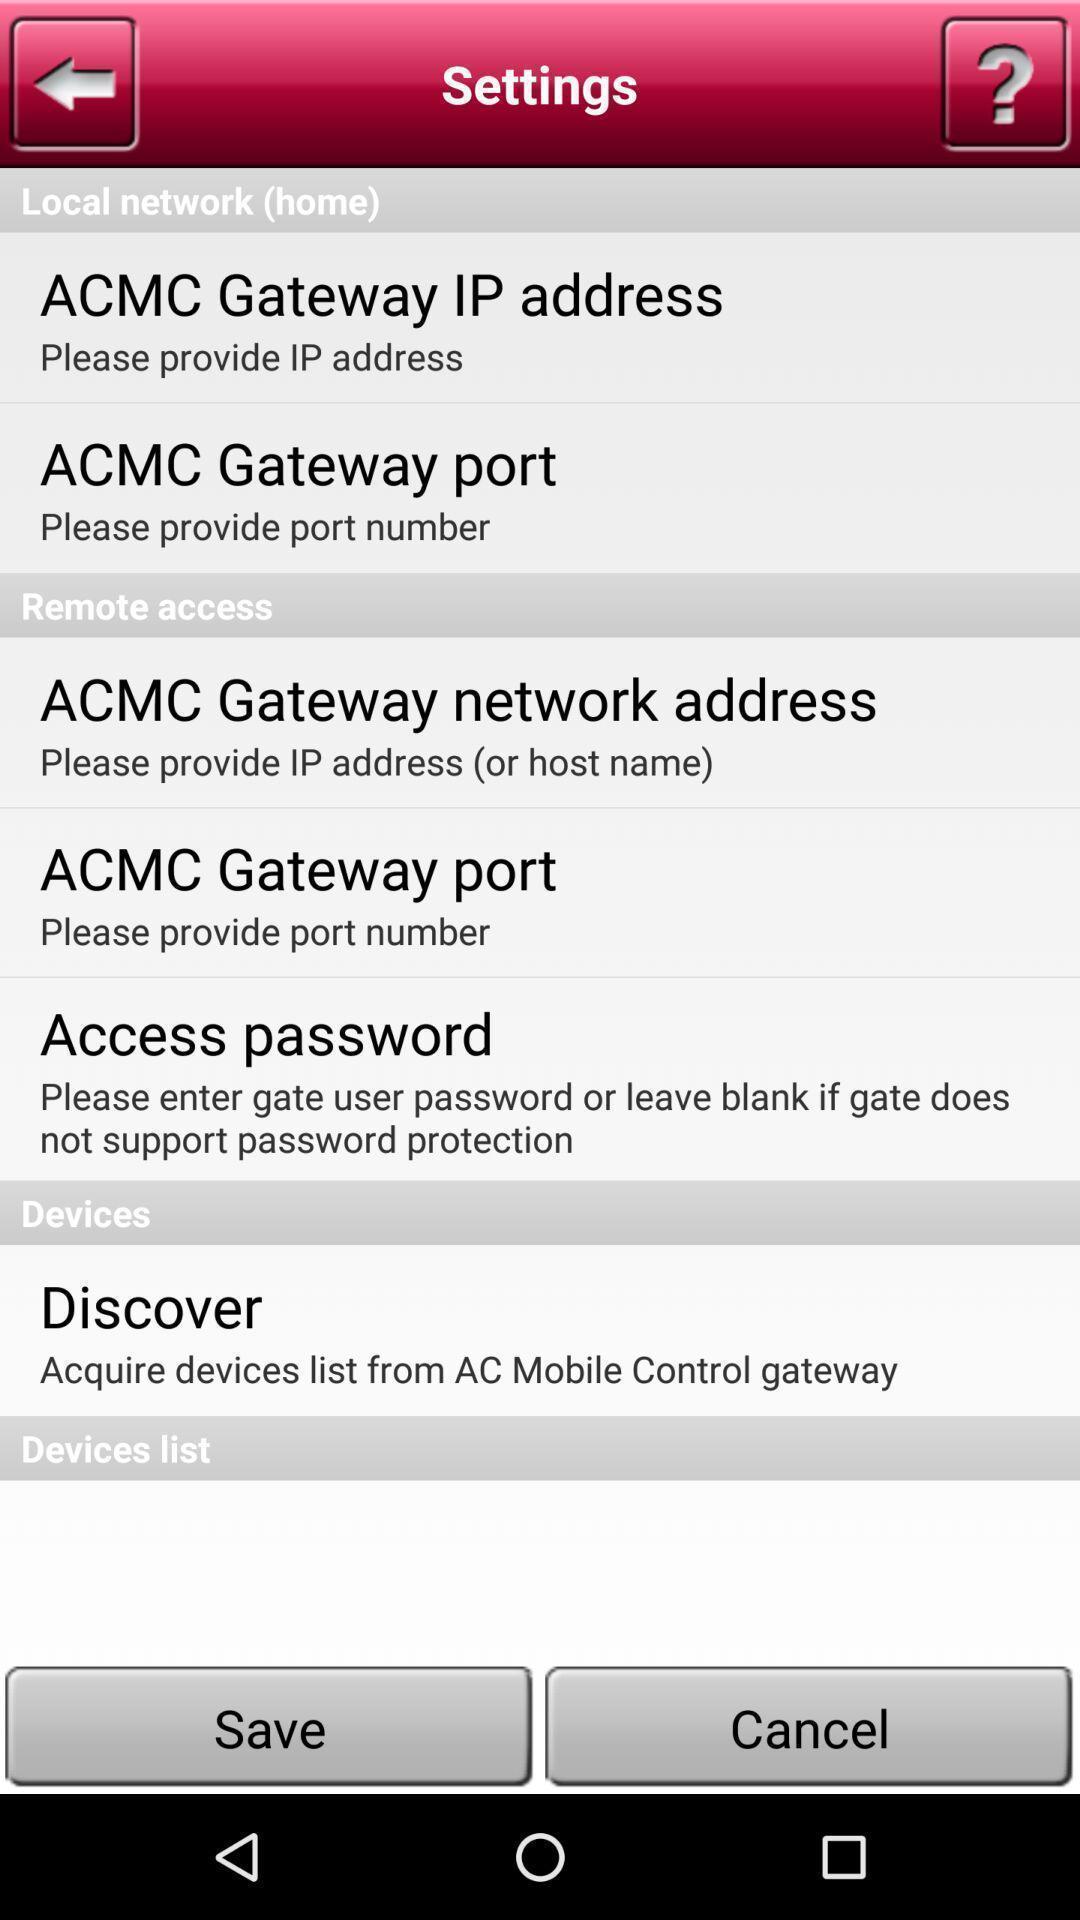Describe the visual elements of this screenshot. Settings page. 